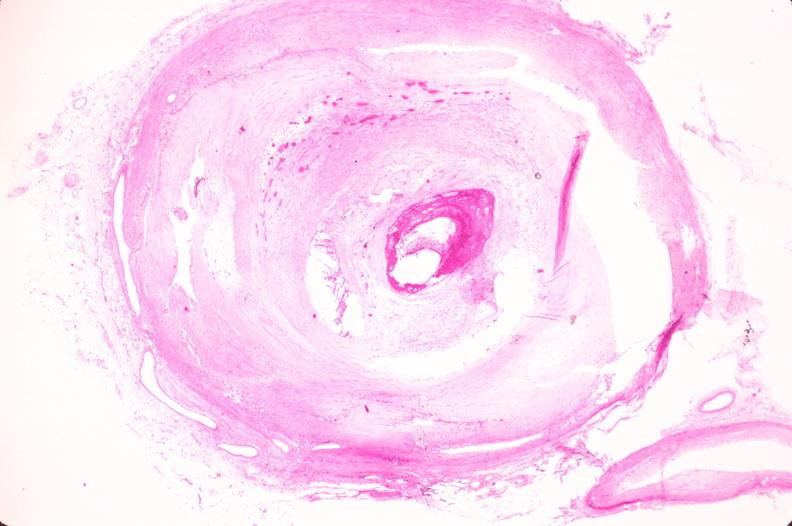s atrophy present?
Answer the question using a single word or phrase. No 